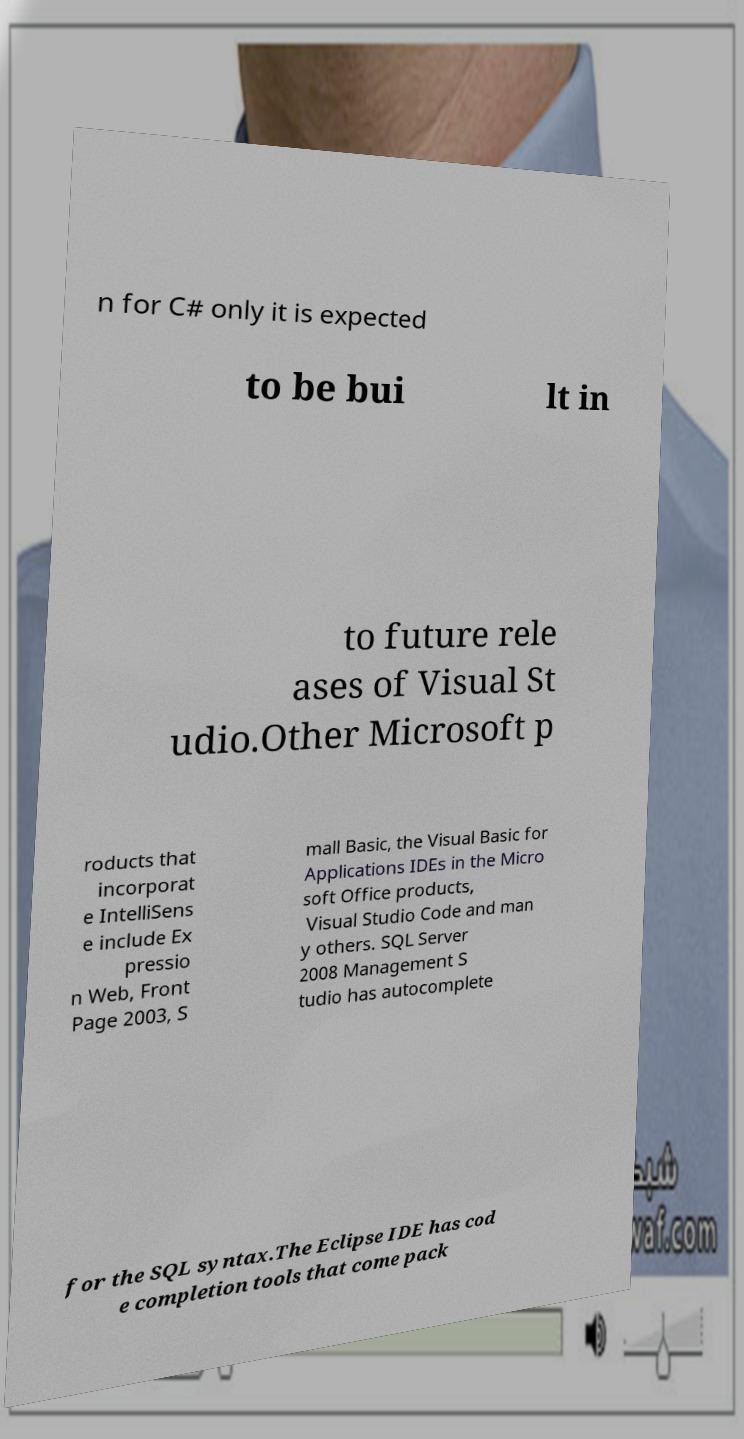Can you accurately transcribe the text from the provided image for me? n for C# only it is expected to be bui lt in to future rele ases of Visual St udio.Other Microsoft p roducts that incorporat e IntelliSens e include Ex pressio n Web, Front Page 2003, S mall Basic, the Visual Basic for Applications IDEs in the Micro soft Office products, Visual Studio Code and man y others. SQL Server 2008 Management S tudio has autocomplete for the SQL syntax.The Eclipse IDE has cod e completion tools that come pack 